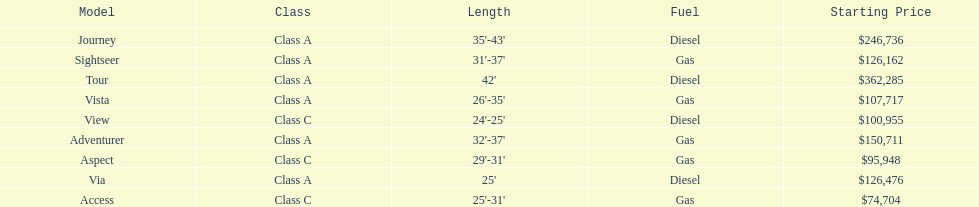Which model is at the top of the list with the highest starting price? Tour. 